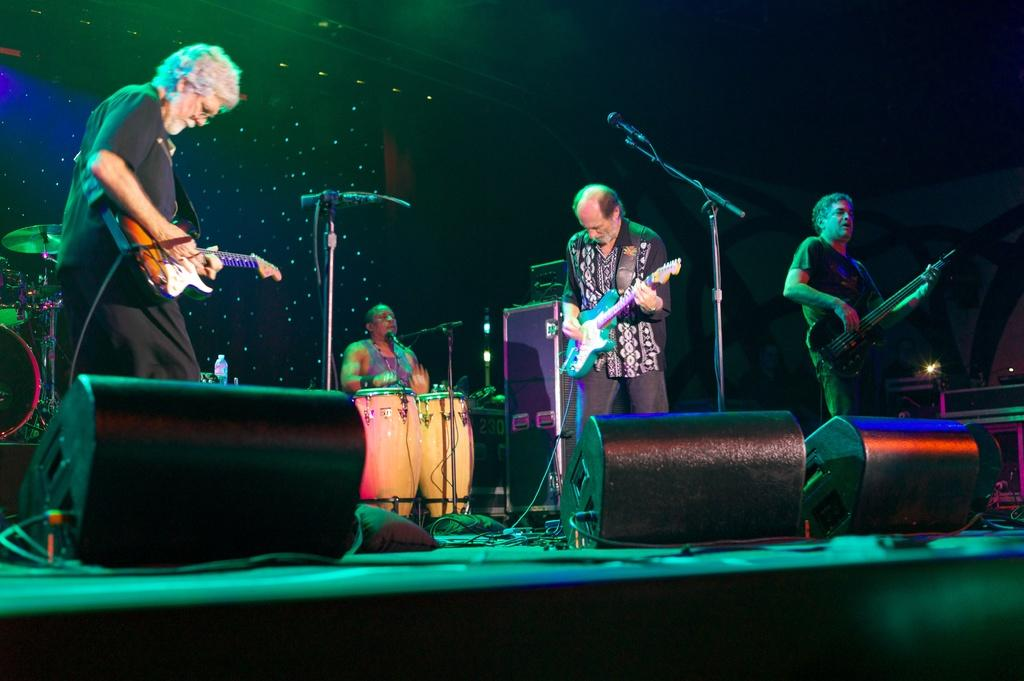Who is present in the image? There are people in the image. What are the people doing in the image? The people are holding musical instruments and playing them. Where is the scene taking place? The scene takes place on a stage. What equipment is present on the stage? There are speakers on the stage. What type of ant can be seen crawling on the stage in the image? There are no ants present in the image; it features people playing musical instruments on a stage. What does the stage smell like in the image? The image does not provide any information about the smell of the stage. 